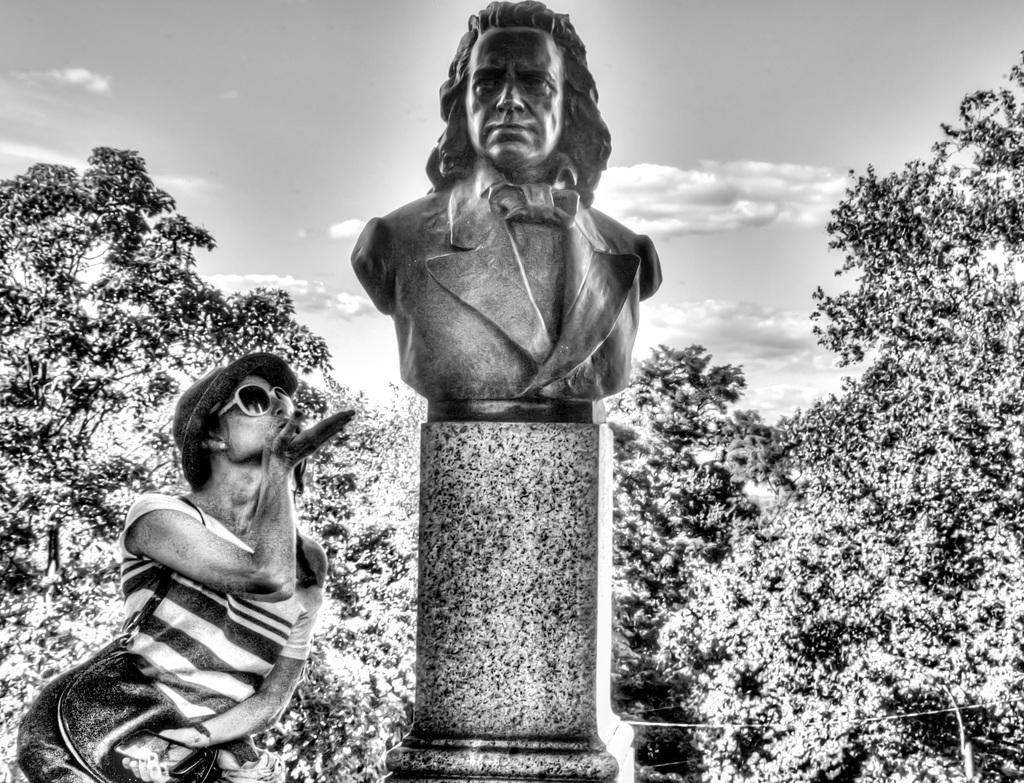What is the main subject in the image? There is a statue in the image. Can you describe the person in the image? The person is wearing a handbag and is beside the statue. What can be seen in the background of the image? There are trees and the sky visible in the background of the image. What type of beetle can be seen crawling on the statue in the image? There is no beetle present on the statue in the image. What part of the statue is the snail attached to in the image? There is no snail present on the statue in the image. 